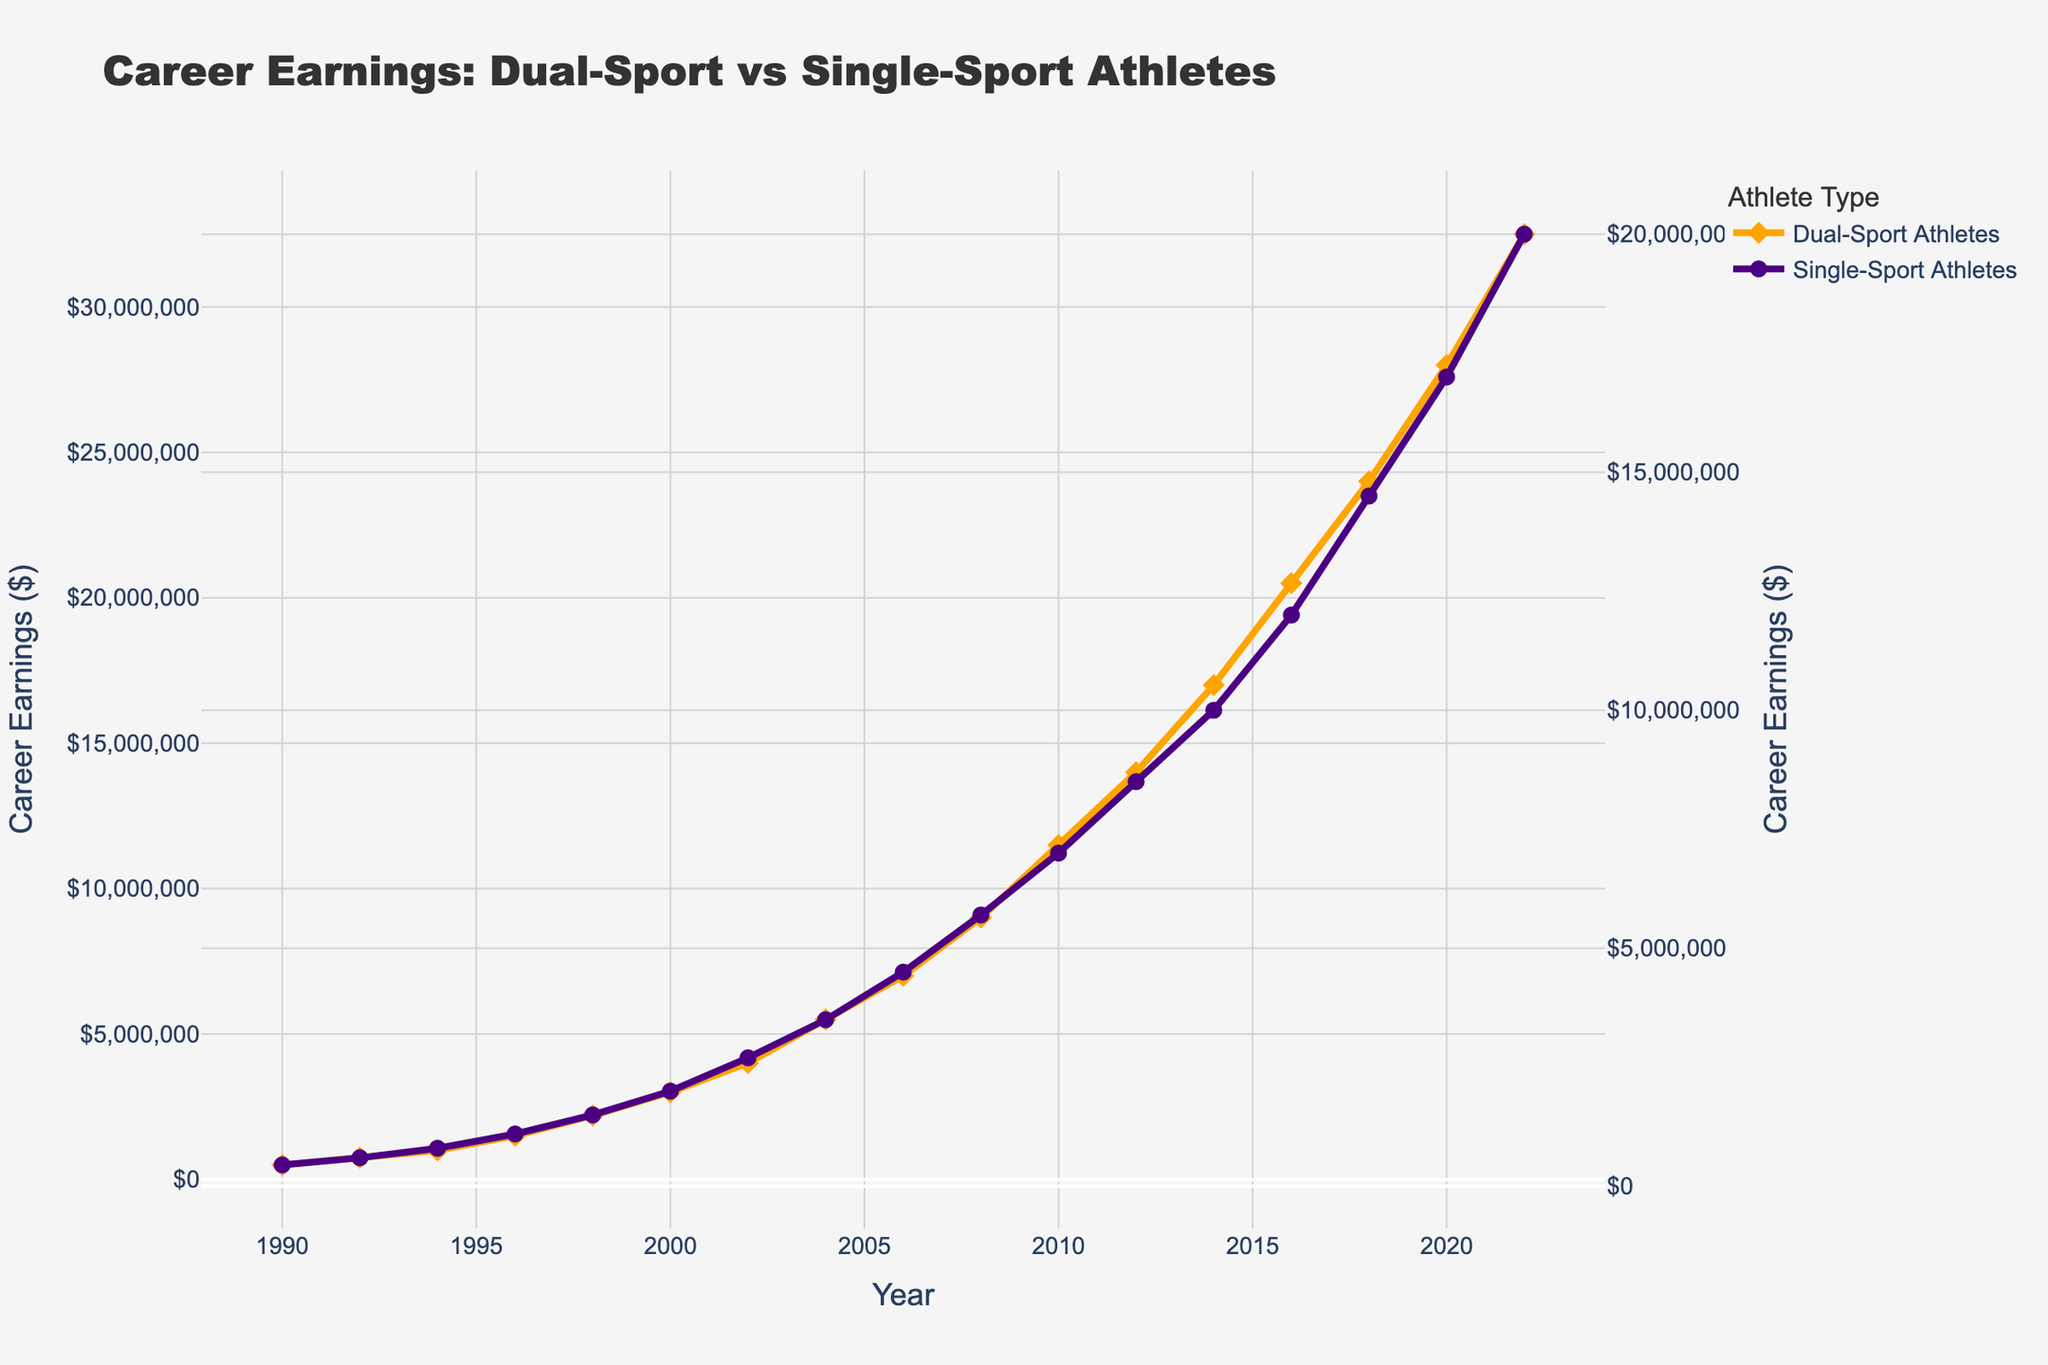What's the total career earnings for Dual-Sport Athletes and Single-Sport Athletes in 2008? For Dual-Sport Athletes in 2008, the career earnings are $9,000,000, and for Single-Sport Athletes, it's $5,700,000. Summing them up: $9,000,000 + $5,700,000 = $14,700,000
Answer: $14,700,000 Which athlete type had higher career earnings in 2000, and by how much? In 2000, Dual-Sport Athletes had career earnings of $3,000,000, while Single-Sport Athletes had $2,000,000. The difference is $3,000,000 - $2,000,000 = $1,000,000
Answer: Dual-Sport Athletes by $1,000,000 How did the career earnings for Single-Sport Athletes change from 2010 to 2012? In 2010, the career earnings were $7,000,000, and in 2012, they increased to $8,500,000. The change is $8,500,000 - $7,000,000 = $1,500,000
Answer: Increased by $1,500,000 What can you infer about the growth trend for Dual-Sport Athletes' career earnings between 1990 and 2022? The career earnings for Dual-Sport Athletes show a steep and consistent increasing trend from $500,000 in 1990 to $32,500,000 in 2022. The visual pattern indicates significant growth over time, especially rapid after the year 2000
Answer: Consistently increasing Between which years did Single-Sport Athletes experience the highest earnings growth rate? By visual inspection, between 2016 and 2018, there is a steep rise where the earnings increase from $12,000,000 to $14,500,000. The growth rate is high during this period
Answer: 2016 to 2018 In what year did Dual-Sport Athletes reach the $10,000,000 career earnings mark? The visual data shows that Dual-Sport Athletes surpassed the $10,000,000 mark in 2010 as the point lies just above this value
Answer: 2010 What is the difference in career earnings between Dual-Sport and Single-Sport Athletes in 2022? For 2022, Dual-Sport Athletes earned $32,500,000, and Single-Sport Athletes earned $20,000,000. The difference is $32,500,000 - $20,000,000 = $12,500,000
Answer: $12,500,000 How many times greater were the career earnings of Dual-Sport Athletes compared to Single-Sport Athletes in 2014? Dual-Sport Athletes earned $17,000,000, and Single-Sport Athletes earned $10,000,000 in 2014. The ratio is $17,000,000 / $10,000,000 = 1.7 times
Answer: 1.7 times What is the average career earnings for Single-Sport Athletes over the entire period? Sum of Single-Sport Athletes' earnings from 1990 to 2022 is $219,500,000, and there are 17 data points. The average is $219,500,000 / 17 ≈ $12,911,764.71
Answer: $12,911,764.71 